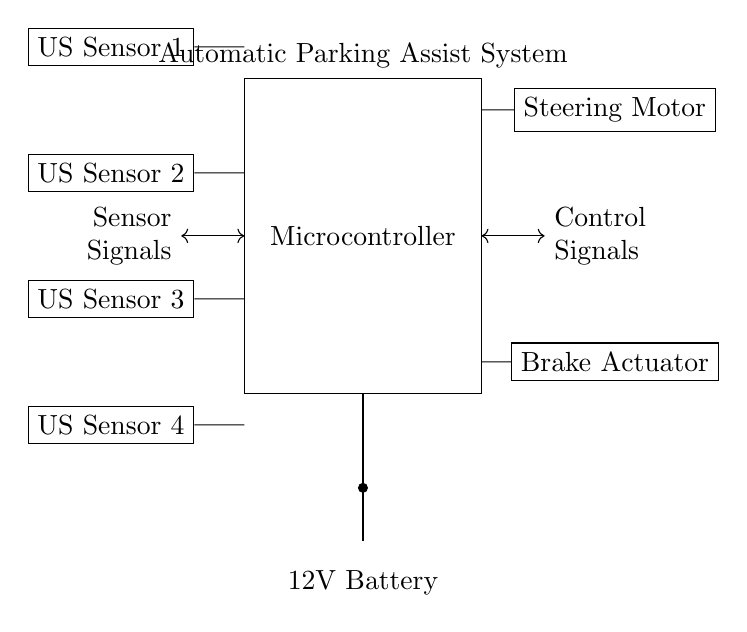What is the main component of this circuit? The main component is the microcontroller, which is the central unit that processes signals from the ultrasonic sensors and controls the actuators.
Answer: microcontroller How many ultrasonic sensors are in the circuit? There are four ultrasonic sensors, as indicated by the four separate blocks labeled US Sensor 1, US Sensor 2, US Sensor 3, and US Sensor 4.
Answer: four What do the arrows represent in the circuit? The arrows represent the direction of the signals being transmitted between the microcontroller, ultrasonic sensors, and actuators, indicating the flow of data and control signals in the system.
Answer: signal direction What are the two types of actuators shown in the circuit? The two types of actuators are the steering motor and the brake actuator, which are responsible for controlling the vehicle's movement during automatic parking.
Answer: steering motor and brake actuator What is the voltage supply for this circuit? The voltage supply is a 12V battery, as indicated by the battery symbol at the bottom of the circuit diagram, which provides the necessary power for the components.
Answer: 12V Which component receives sensor signals? The microcontroller receives the sensor signals from the four ultrasonic sensors and processes them to make decisions for the actuators.
Answer: microcontroller What is the function of the steering motor in this circuit? The steering motor functions to control the direction of the vehicle during the automatic parking process, allowing for precise maneuvering based on the sensor data processed by the microcontroller.
Answer: control direction 